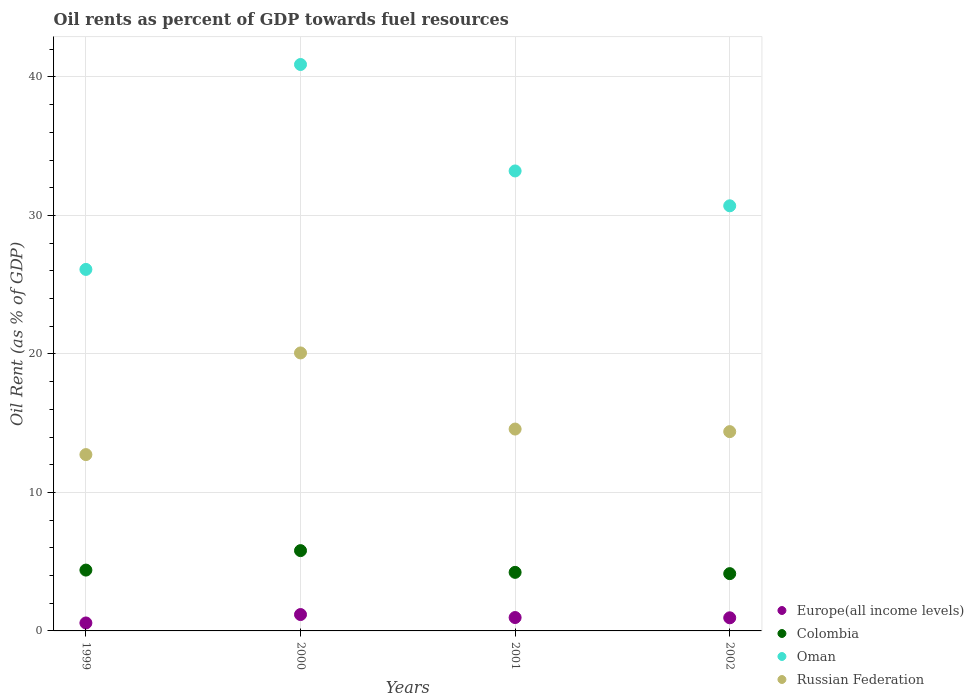How many different coloured dotlines are there?
Your answer should be very brief. 4. What is the oil rent in Oman in 2002?
Your response must be concise. 30.69. Across all years, what is the maximum oil rent in Europe(all income levels)?
Keep it short and to the point. 1.18. Across all years, what is the minimum oil rent in Colombia?
Keep it short and to the point. 4.14. In which year was the oil rent in Colombia maximum?
Your answer should be very brief. 2000. In which year was the oil rent in Europe(all income levels) minimum?
Give a very brief answer. 1999. What is the total oil rent in Europe(all income levels) in the graph?
Keep it short and to the point. 3.67. What is the difference between the oil rent in Russian Federation in 2001 and that in 2002?
Offer a terse response. 0.19. What is the difference between the oil rent in Oman in 2002 and the oil rent in Russian Federation in 1999?
Your response must be concise. 17.96. What is the average oil rent in Russian Federation per year?
Your answer should be very brief. 15.44. In the year 2002, what is the difference between the oil rent in Russian Federation and oil rent in Oman?
Keep it short and to the point. -16.3. In how many years, is the oil rent in Europe(all income levels) greater than 24 %?
Ensure brevity in your answer.  0. What is the ratio of the oil rent in Russian Federation in 1999 to that in 2002?
Your response must be concise. 0.88. Is the oil rent in Russian Federation in 1999 less than that in 2000?
Your answer should be compact. Yes. What is the difference between the highest and the second highest oil rent in Oman?
Your answer should be very brief. 7.69. What is the difference between the highest and the lowest oil rent in Europe(all income levels)?
Give a very brief answer. 0.61. In how many years, is the oil rent in Oman greater than the average oil rent in Oman taken over all years?
Offer a very short reply. 2. Is the sum of the oil rent in Russian Federation in 2000 and 2001 greater than the maximum oil rent in Oman across all years?
Keep it short and to the point. No. Does the oil rent in Colombia monotonically increase over the years?
Your answer should be very brief. No. Is the oil rent in Oman strictly less than the oil rent in Russian Federation over the years?
Your answer should be compact. No. How many dotlines are there?
Offer a terse response. 4. Does the graph contain any zero values?
Offer a terse response. No. Does the graph contain grids?
Provide a succinct answer. Yes. Where does the legend appear in the graph?
Your answer should be compact. Bottom right. How many legend labels are there?
Make the answer very short. 4. How are the legend labels stacked?
Offer a very short reply. Vertical. What is the title of the graph?
Ensure brevity in your answer.  Oil rents as percent of GDP towards fuel resources. Does "Uruguay" appear as one of the legend labels in the graph?
Ensure brevity in your answer.  No. What is the label or title of the Y-axis?
Your answer should be very brief. Oil Rent (as % of GDP). What is the Oil Rent (as % of GDP) of Europe(all income levels) in 1999?
Your response must be concise. 0.58. What is the Oil Rent (as % of GDP) in Colombia in 1999?
Make the answer very short. 4.39. What is the Oil Rent (as % of GDP) in Oman in 1999?
Offer a terse response. 26.1. What is the Oil Rent (as % of GDP) of Russian Federation in 1999?
Provide a succinct answer. 12.73. What is the Oil Rent (as % of GDP) of Europe(all income levels) in 2000?
Offer a terse response. 1.18. What is the Oil Rent (as % of GDP) of Colombia in 2000?
Keep it short and to the point. 5.8. What is the Oil Rent (as % of GDP) in Oman in 2000?
Give a very brief answer. 40.9. What is the Oil Rent (as % of GDP) of Russian Federation in 2000?
Your answer should be very brief. 20.07. What is the Oil Rent (as % of GDP) of Europe(all income levels) in 2001?
Offer a terse response. 0.97. What is the Oil Rent (as % of GDP) of Colombia in 2001?
Your answer should be compact. 4.23. What is the Oil Rent (as % of GDP) of Oman in 2001?
Your answer should be very brief. 33.21. What is the Oil Rent (as % of GDP) in Russian Federation in 2001?
Provide a succinct answer. 14.57. What is the Oil Rent (as % of GDP) of Europe(all income levels) in 2002?
Ensure brevity in your answer.  0.95. What is the Oil Rent (as % of GDP) in Colombia in 2002?
Your response must be concise. 4.14. What is the Oil Rent (as % of GDP) in Oman in 2002?
Ensure brevity in your answer.  30.69. What is the Oil Rent (as % of GDP) in Russian Federation in 2002?
Provide a succinct answer. 14.39. Across all years, what is the maximum Oil Rent (as % of GDP) of Europe(all income levels)?
Your answer should be compact. 1.18. Across all years, what is the maximum Oil Rent (as % of GDP) in Colombia?
Make the answer very short. 5.8. Across all years, what is the maximum Oil Rent (as % of GDP) in Oman?
Your answer should be very brief. 40.9. Across all years, what is the maximum Oil Rent (as % of GDP) in Russian Federation?
Make the answer very short. 20.07. Across all years, what is the minimum Oil Rent (as % of GDP) in Europe(all income levels)?
Offer a terse response. 0.58. Across all years, what is the minimum Oil Rent (as % of GDP) of Colombia?
Your answer should be compact. 4.14. Across all years, what is the minimum Oil Rent (as % of GDP) in Oman?
Give a very brief answer. 26.1. Across all years, what is the minimum Oil Rent (as % of GDP) in Russian Federation?
Your answer should be compact. 12.73. What is the total Oil Rent (as % of GDP) in Europe(all income levels) in the graph?
Provide a succinct answer. 3.67. What is the total Oil Rent (as % of GDP) of Colombia in the graph?
Your response must be concise. 18.55. What is the total Oil Rent (as % of GDP) in Oman in the graph?
Keep it short and to the point. 130.9. What is the total Oil Rent (as % of GDP) in Russian Federation in the graph?
Give a very brief answer. 61.77. What is the difference between the Oil Rent (as % of GDP) of Europe(all income levels) in 1999 and that in 2000?
Offer a terse response. -0.61. What is the difference between the Oil Rent (as % of GDP) of Colombia in 1999 and that in 2000?
Ensure brevity in your answer.  -1.41. What is the difference between the Oil Rent (as % of GDP) of Oman in 1999 and that in 2000?
Offer a very short reply. -14.8. What is the difference between the Oil Rent (as % of GDP) in Russian Federation in 1999 and that in 2000?
Make the answer very short. -7.34. What is the difference between the Oil Rent (as % of GDP) of Europe(all income levels) in 1999 and that in 2001?
Keep it short and to the point. -0.39. What is the difference between the Oil Rent (as % of GDP) of Colombia in 1999 and that in 2001?
Your answer should be compact. 0.16. What is the difference between the Oil Rent (as % of GDP) of Oman in 1999 and that in 2001?
Ensure brevity in your answer.  -7.11. What is the difference between the Oil Rent (as % of GDP) in Russian Federation in 1999 and that in 2001?
Ensure brevity in your answer.  -1.84. What is the difference between the Oil Rent (as % of GDP) in Europe(all income levels) in 1999 and that in 2002?
Your response must be concise. -0.37. What is the difference between the Oil Rent (as % of GDP) of Colombia in 1999 and that in 2002?
Your response must be concise. 0.26. What is the difference between the Oil Rent (as % of GDP) in Oman in 1999 and that in 2002?
Give a very brief answer. -4.59. What is the difference between the Oil Rent (as % of GDP) of Russian Federation in 1999 and that in 2002?
Your answer should be very brief. -1.66. What is the difference between the Oil Rent (as % of GDP) in Europe(all income levels) in 2000 and that in 2001?
Make the answer very short. 0.22. What is the difference between the Oil Rent (as % of GDP) in Colombia in 2000 and that in 2001?
Keep it short and to the point. 1.57. What is the difference between the Oil Rent (as % of GDP) in Oman in 2000 and that in 2001?
Give a very brief answer. 7.69. What is the difference between the Oil Rent (as % of GDP) of Russian Federation in 2000 and that in 2001?
Give a very brief answer. 5.5. What is the difference between the Oil Rent (as % of GDP) of Europe(all income levels) in 2000 and that in 2002?
Your response must be concise. 0.24. What is the difference between the Oil Rent (as % of GDP) in Colombia in 2000 and that in 2002?
Keep it short and to the point. 1.66. What is the difference between the Oil Rent (as % of GDP) of Oman in 2000 and that in 2002?
Offer a very short reply. 10.2. What is the difference between the Oil Rent (as % of GDP) of Russian Federation in 2000 and that in 2002?
Offer a very short reply. 5.68. What is the difference between the Oil Rent (as % of GDP) of Europe(all income levels) in 2001 and that in 2002?
Provide a succinct answer. 0.02. What is the difference between the Oil Rent (as % of GDP) in Colombia in 2001 and that in 2002?
Provide a succinct answer. 0.09. What is the difference between the Oil Rent (as % of GDP) of Oman in 2001 and that in 2002?
Your answer should be very brief. 2.52. What is the difference between the Oil Rent (as % of GDP) in Russian Federation in 2001 and that in 2002?
Offer a very short reply. 0.19. What is the difference between the Oil Rent (as % of GDP) in Europe(all income levels) in 1999 and the Oil Rent (as % of GDP) in Colombia in 2000?
Your answer should be compact. -5.22. What is the difference between the Oil Rent (as % of GDP) of Europe(all income levels) in 1999 and the Oil Rent (as % of GDP) of Oman in 2000?
Provide a succinct answer. -40.32. What is the difference between the Oil Rent (as % of GDP) in Europe(all income levels) in 1999 and the Oil Rent (as % of GDP) in Russian Federation in 2000?
Your answer should be compact. -19.5. What is the difference between the Oil Rent (as % of GDP) of Colombia in 1999 and the Oil Rent (as % of GDP) of Oman in 2000?
Offer a terse response. -36.5. What is the difference between the Oil Rent (as % of GDP) in Colombia in 1999 and the Oil Rent (as % of GDP) in Russian Federation in 2000?
Provide a succinct answer. -15.68. What is the difference between the Oil Rent (as % of GDP) of Oman in 1999 and the Oil Rent (as % of GDP) of Russian Federation in 2000?
Provide a succinct answer. 6.03. What is the difference between the Oil Rent (as % of GDP) in Europe(all income levels) in 1999 and the Oil Rent (as % of GDP) in Colombia in 2001?
Provide a succinct answer. -3.65. What is the difference between the Oil Rent (as % of GDP) in Europe(all income levels) in 1999 and the Oil Rent (as % of GDP) in Oman in 2001?
Ensure brevity in your answer.  -32.64. What is the difference between the Oil Rent (as % of GDP) in Europe(all income levels) in 1999 and the Oil Rent (as % of GDP) in Russian Federation in 2001?
Ensure brevity in your answer.  -14. What is the difference between the Oil Rent (as % of GDP) in Colombia in 1999 and the Oil Rent (as % of GDP) in Oman in 2001?
Offer a terse response. -28.82. What is the difference between the Oil Rent (as % of GDP) in Colombia in 1999 and the Oil Rent (as % of GDP) in Russian Federation in 2001?
Make the answer very short. -10.18. What is the difference between the Oil Rent (as % of GDP) in Oman in 1999 and the Oil Rent (as % of GDP) in Russian Federation in 2001?
Offer a very short reply. 11.53. What is the difference between the Oil Rent (as % of GDP) in Europe(all income levels) in 1999 and the Oil Rent (as % of GDP) in Colombia in 2002?
Provide a succinct answer. -3.56. What is the difference between the Oil Rent (as % of GDP) of Europe(all income levels) in 1999 and the Oil Rent (as % of GDP) of Oman in 2002?
Offer a terse response. -30.12. What is the difference between the Oil Rent (as % of GDP) of Europe(all income levels) in 1999 and the Oil Rent (as % of GDP) of Russian Federation in 2002?
Provide a short and direct response. -13.81. What is the difference between the Oil Rent (as % of GDP) in Colombia in 1999 and the Oil Rent (as % of GDP) in Oman in 2002?
Keep it short and to the point. -26.3. What is the difference between the Oil Rent (as % of GDP) in Colombia in 1999 and the Oil Rent (as % of GDP) in Russian Federation in 2002?
Offer a very short reply. -10. What is the difference between the Oil Rent (as % of GDP) in Oman in 1999 and the Oil Rent (as % of GDP) in Russian Federation in 2002?
Offer a terse response. 11.71. What is the difference between the Oil Rent (as % of GDP) of Europe(all income levels) in 2000 and the Oil Rent (as % of GDP) of Colombia in 2001?
Keep it short and to the point. -3.05. What is the difference between the Oil Rent (as % of GDP) in Europe(all income levels) in 2000 and the Oil Rent (as % of GDP) in Oman in 2001?
Your response must be concise. -32.03. What is the difference between the Oil Rent (as % of GDP) of Europe(all income levels) in 2000 and the Oil Rent (as % of GDP) of Russian Federation in 2001?
Provide a succinct answer. -13.39. What is the difference between the Oil Rent (as % of GDP) of Colombia in 2000 and the Oil Rent (as % of GDP) of Oman in 2001?
Ensure brevity in your answer.  -27.41. What is the difference between the Oil Rent (as % of GDP) of Colombia in 2000 and the Oil Rent (as % of GDP) of Russian Federation in 2001?
Make the answer very short. -8.78. What is the difference between the Oil Rent (as % of GDP) in Oman in 2000 and the Oil Rent (as % of GDP) in Russian Federation in 2001?
Your answer should be very brief. 26.32. What is the difference between the Oil Rent (as % of GDP) in Europe(all income levels) in 2000 and the Oil Rent (as % of GDP) in Colombia in 2002?
Ensure brevity in your answer.  -2.95. What is the difference between the Oil Rent (as % of GDP) of Europe(all income levels) in 2000 and the Oil Rent (as % of GDP) of Oman in 2002?
Offer a very short reply. -29.51. What is the difference between the Oil Rent (as % of GDP) of Europe(all income levels) in 2000 and the Oil Rent (as % of GDP) of Russian Federation in 2002?
Provide a succinct answer. -13.21. What is the difference between the Oil Rent (as % of GDP) in Colombia in 2000 and the Oil Rent (as % of GDP) in Oman in 2002?
Your answer should be compact. -24.9. What is the difference between the Oil Rent (as % of GDP) in Colombia in 2000 and the Oil Rent (as % of GDP) in Russian Federation in 2002?
Your response must be concise. -8.59. What is the difference between the Oil Rent (as % of GDP) in Oman in 2000 and the Oil Rent (as % of GDP) in Russian Federation in 2002?
Make the answer very short. 26.51. What is the difference between the Oil Rent (as % of GDP) in Europe(all income levels) in 2001 and the Oil Rent (as % of GDP) in Colombia in 2002?
Keep it short and to the point. -3.17. What is the difference between the Oil Rent (as % of GDP) of Europe(all income levels) in 2001 and the Oil Rent (as % of GDP) of Oman in 2002?
Keep it short and to the point. -29.73. What is the difference between the Oil Rent (as % of GDP) in Europe(all income levels) in 2001 and the Oil Rent (as % of GDP) in Russian Federation in 2002?
Offer a terse response. -13.42. What is the difference between the Oil Rent (as % of GDP) of Colombia in 2001 and the Oil Rent (as % of GDP) of Oman in 2002?
Provide a short and direct response. -26.47. What is the difference between the Oil Rent (as % of GDP) of Colombia in 2001 and the Oil Rent (as % of GDP) of Russian Federation in 2002?
Your answer should be very brief. -10.16. What is the difference between the Oil Rent (as % of GDP) of Oman in 2001 and the Oil Rent (as % of GDP) of Russian Federation in 2002?
Keep it short and to the point. 18.82. What is the average Oil Rent (as % of GDP) of Europe(all income levels) per year?
Keep it short and to the point. 0.92. What is the average Oil Rent (as % of GDP) of Colombia per year?
Provide a short and direct response. 4.64. What is the average Oil Rent (as % of GDP) of Oman per year?
Your response must be concise. 32.73. What is the average Oil Rent (as % of GDP) of Russian Federation per year?
Offer a terse response. 15.44. In the year 1999, what is the difference between the Oil Rent (as % of GDP) in Europe(all income levels) and Oil Rent (as % of GDP) in Colombia?
Offer a very short reply. -3.82. In the year 1999, what is the difference between the Oil Rent (as % of GDP) of Europe(all income levels) and Oil Rent (as % of GDP) of Oman?
Provide a succinct answer. -25.53. In the year 1999, what is the difference between the Oil Rent (as % of GDP) in Europe(all income levels) and Oil Rent (as % of GDP) in Russian Federation?
Your answer should be compact. -12.16. In the year 1999, what is the difference between the Oil Rent (as % of GDP) of Colombia and Oil Rent (as % of GDP) of Oman?
Provide a short and direct response. -21.71. In the year 1999, what is the difference between the Oil Rent (as % of GDP) in Colombia and Oil Rent (as % of GDP) in Russian Federation?
Offer a terse response. -8.34. In the year 1999, what is the difference between the Oil Rent (as % of GDP) of Oman and Oil Rent (as % of GDP) of Russian Federation?
Keep it short and to the point. 13.37. In the year 2000, what is the difference between the Oil Rent (as % of GDP) in Europe(all income levels) and Oil Rent (as % of GDP) in Colombia?
Offer a terse response. -4.62. In the year 2000, what is the difference between the Oil Rent (as % of GDP) of Europe(all income levels) and Oil Rent (as % of GDP) of Oman?
Your response must be concise. -39.71. In the year 2000, what is the difference between the Oil Rent (as % of GDP) in Europe(all income levels) and Oil Rent (as % of GDP) in Russian Federation?
Provide a short and direct response. -18.89. In the year 2000, what is the difference between the Oil Rent (as % of GDP) of Colombia and Oil Rent (as % of GDP) of Oman?
Give a very brief answer. -35.1. In the year 2000, what is the difference between the Oil Rent (as % of GDP) in Colombia and Oil Rent (as % of GDP) in Russian Federation?
Your answer should be very brief. -14.27. In the year 2000, what is the difference between the Oil Rent (as % of GDP) of Oman and Oil Rent (as % of GDP) of Russian Federation?
Ensure brevity in your answer.  20.83. In the year 2001, what is the difference between the Oil Rent (as % of GDP) in Europe(all income levels) and Oil Rent (as % of GDP) in Colombia?
Make the answer very short. -3.26. In the year 2001, what is the difference between the Oil Rent (as % of GDP) of Europe(all income levels) and Oil Rent (as % of GDP) of Oman?
Provide a short and direct response. -32.24. In the year 2001, what is the difference between the Oil Rent (as % of GDP) in Europe(all income levels) and Oil Rent (as % of GDP) in Russian Federation?
Keep it short and to the point. -13.61. In the year 2001, what is the difference between the Oil Rent (as % of GDP) of Colombia and Oil Rent (as % of GDP) of Oman?
Make the answer very short. -28.98. In the year 2001, what is the difference between the Oil Rent (as % of GDP) in Colombia and Oil Rent (as % of GDP) in Russian Federation?
Offer a very short reply. -10.35. In the year 2001, what is the difference between the Oil Rent (as % of GDP) of Oman and Oil Rent (as % of GDP) of Russian Federation?
Make the answer very short. 18.64. In the year 2002, what is the difference between the Oil Rent (as % of GDP) of Europe(all income levels) and Oil Rent (as % of GDP) of Colombia?
Ensure brevity in your answer.  -3.19. In the year 2002, what is the difference between the Oil Rent (as % of GDP) of Europe(all income levels) and Oil Rent (as % of GDP) of Oman?
Ensure brevity in your answer.  -29.75. In the year 2002, what is the difference between the Oil Rent (as % of GDP) in Europe(all income levels) and Oil Rent (as % of GDP) in Russian Federation?
Keep it short and to the point. -13.44. In the year 2002, what is the difference between the Oil Rent (as % of GDP) of Colombia and Oil Rent (as % of GDP) of Oman?
Offer a very short reply. -26.56. In the year 2002, what is the difference between the Oil Rent (as % of GDP) in Colombia and Oil Rent (as % of GDP) in Russian Federation?
Keep it short and to the point. -10.25. In the year 2002, what is the difference between the Oil Rent (as % of GDP) in Oman and Oil Rent (as % of GDP) in Russian Federation?
Keep it short and to the point. 16.3. What is the ratio of the Oil Rent (as % of GDP) in Europe(all income levels) in 1999 to that in 2000?
Make the answer very short. 0.49. What is the ratio of the Oil Rent (as % of GDP) of Colombia in 1999 to that in 2000?
Your response must be concise. 0.76. What is the ratio of the Oil Rent (as % of GDP) in Oman in 1999 to that in 2000?
Keep it short and to the point. 0.64. What is the ratio of the Oil Rent (as % of GDP) in Russian Federation in 1999 to that in 2000?
Your answer should be compact. 0.63. What is the ratio of the Oil Rent (as % of GDP) in Europe(all income levels) in 1999 to that in 2001?
Offer a terse response. 0.6. What is the ratio of the Oil Rent (as % of GDP) in Colombia in 1999 to that in 2001?
Offer a terse response. 1.04. What is the ratio of the Oil Rent (as % of GDP) of Oman in 1999 to that in 2001?
Offer a very short reply. 0.79. What is the ratio of the Oil Rent (as % of GDP) in Russian Federation in 1999 to that in 2001?
Ensure brevity in your answer.  0.87. What is the ratio of the Oil Rent (as % of GDP) of Europe(all income levels) in 1999 to that in 2002?
Your response must be concise. 0.61. What is the ratio of the Oil Rent (as % of GDP) in Colombia in 1999 to that in 2002?
Provide a succinct answer. 1.06. What is the ratio of the Oil Rent (as % of GDP) in Oman in 1999 to that in 2002?
Keep it short and to the point. 0.85. What is the ratio of the Oil Rent (as % of GDP) in Russian Federation in 1999 to that in 2002?
Give a very brief answer. 0.88. What is the ratio of the Oil Rent (as % of GDP) of Europe(all income levels) in 2000 to that in 2001?
Your response must be concise. 1.22. What is the ratio of the Oil Rent (as % of GDP) of Colombia in 2000 to that in 2001?
Provide a short and direct response. 1.37. What is the ratio of the Oil Rent (as % of GDP) in Oman in 2000 to that in 2001?
Give a very brief answer. 1.23. What is the ratio of the Oil Rent (as % of GDP) of Russian Federation in 2000 to that in 2001?
Keep it short and to the point. 1.38. What is the ratio of the Oil Rent (as % of GDP) in Europe(all income levels) in 2000 to that in 2002?
Provide a short and direct response. 1.25. What is the ratio of the Oil Rent (as % of GDP) in Colombia in 2000 to that in 2002?
Offer a very short reply. 1.4. What is the ratio of the Oil Rent (as % of GDP) of Oman in 2000 to that in 2002?
Give a very brief answer. 1.33. What is the ratio of the Oil Rent (as % of GDP) in Russian Federation in 2000 to that in 2002?
Make the answer very short. 1.39. What is the ratio of the Oil Rent (as % of GDP) of Europe(all income levels) in 2001 to that in 2002?
Your answer should be very brief. 1.02. What is the ratio of the Oil Rent (as % of GDP) in Colombia in 2001 to that in 2002?
Provide a short and direct response. 1.02. What is the ratio of the Oil Rent (as % of GDP) of Oman in 2001 to that in 2002?
Your answer should be compact. 1.08. What is the ratio of the Oil Rent (as % of GDP) in Russian Federation in 2001 to that in 2002?
Your answer should be compact. 1.01. What is the difference between the highest and the second highest Oil Rent (as % of GDP) in Europe(all income levels)?
Provide a succinct answer. 0.22. What is the difference between the highest and the second highest Oil Rent (as % of GDP) of Colombia?
Offer a terse response. 1.41. What is the difference between the highest and the second highest Oil Rent (as % of GDP) of Oman?
Offer a terse response. 7.69. What is the difference between the highest and the second highest Oil Rent (as % of GDP) in Russian Federation?
Your answer should be compact. 5.5. What is the difference between the highest and the lowest Oil Rent (as % of GDP) in Europe(all income levels)?
Ensure brevity in your answer.  0.61. What is the difference between the highest and the lowest Oil Rent (as % of GDP) in Colombia?
Give a very brief answer. 1.66. What is the difference between the highest and the lowest Oil Rent (as % of GDP) in Oman?
Ensure brevity in your answer.  14.8. What is the difference between the highest and the lowest Oil Rent (as % of GDP) of Russian Federation?
Your response must be concise. 7.34. 